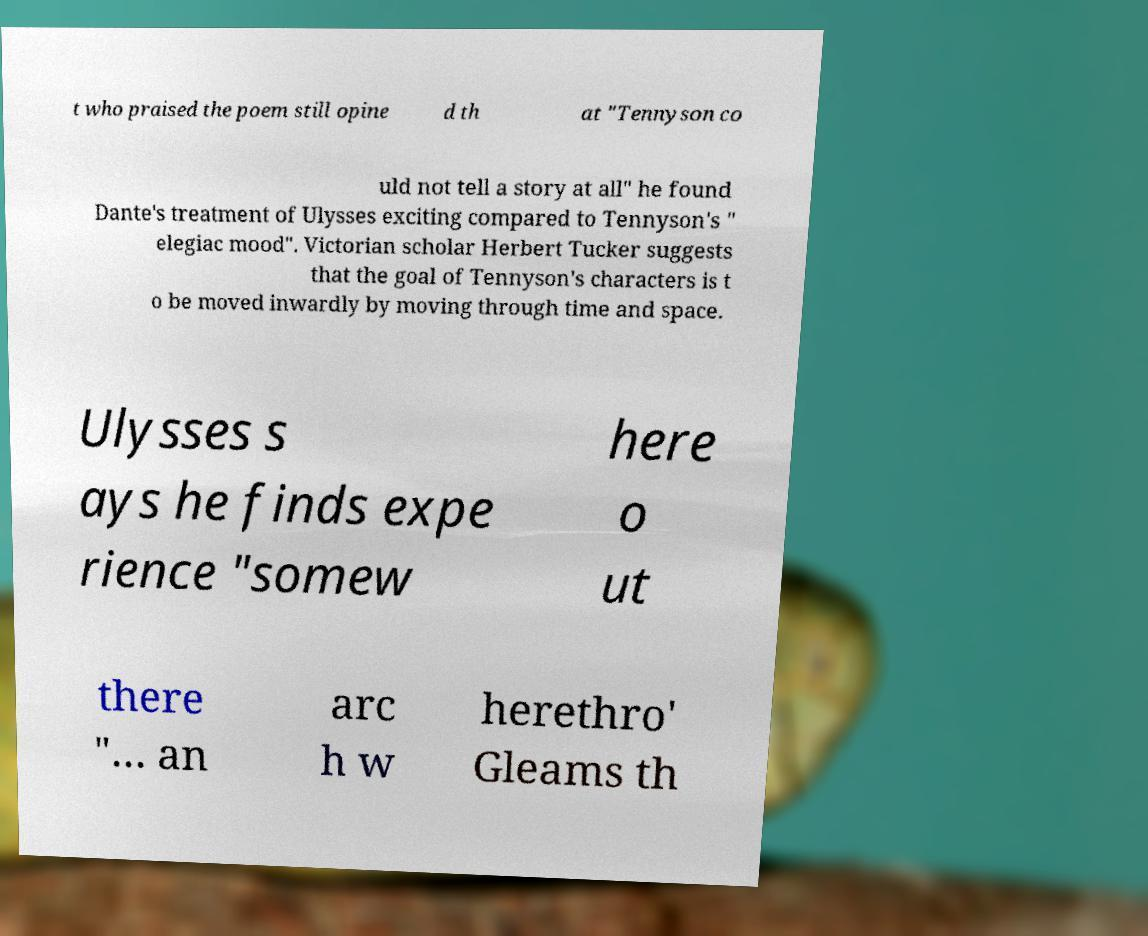Could you assist in decoding the text presented in this image and type it out clearly? t who praised the poem still opine d th at "Tennyson co uld not tell a story at all" he found Dante's treatment of Ulysses exciting compared to Tennyson's " elegiac mood". Victorian scholar Herbert Tucker suggests that the goal of Tennyson's characters is t o be moved inwardly by moving through time and space. Ulysses s ays he finds expe rience "somew here o ut there "… an arc h w herethro' Gleams th 